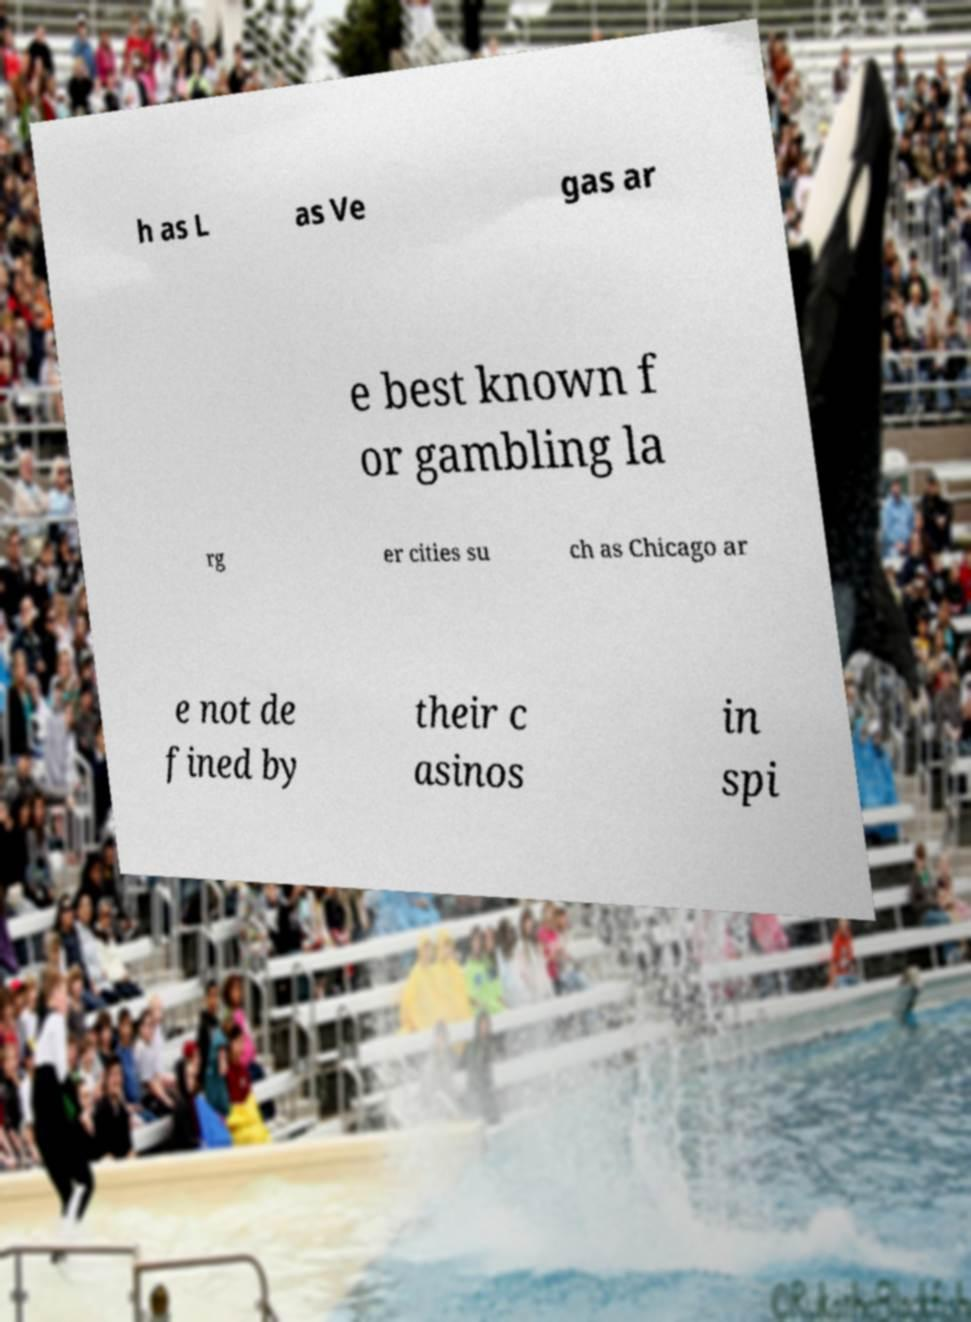Could you extract and type out the text from this image? h as L as Ve gas ar e best known f or gambling la rg er cities su ch as Chicago ar e not de fined by their c asinos in spi 